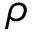<formula> <loc_0><loc_0><loc_500><loc_500>\rho</formula> 